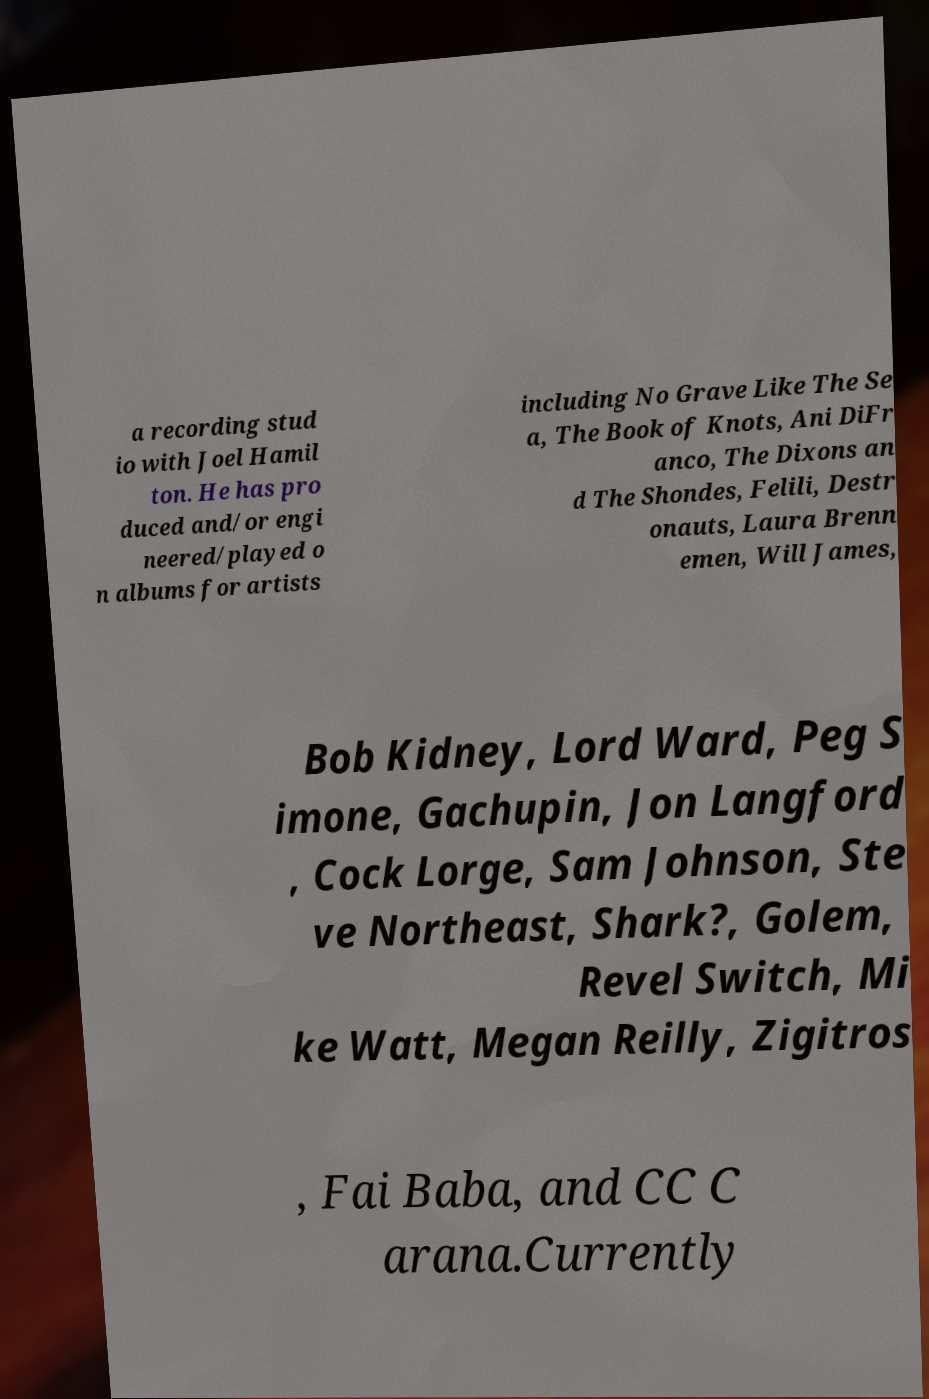Can you accurately transcribe the text from the provided image for me? a recording stud io with Joel Hamil ton. He has pro duced and/or engi neered/played o n albums for artists including No Grave Like The Se a, The Book of Knots, Ani DiFr anco, The Dixons an d The Shondes, Felili, Destr onauts, Laura Brenn emen, Will James, Bob Kidney, Lord Ward, Peg S imone, Gachupin, Jon Langford , Cock Lorge, Sam Johnson, Ste ve Northeast, Shark?, Golem, Revel Switch, Mi ke Watt, Megan Reilly, Zigitros , Fai Baba, and CC C arana.Currently 